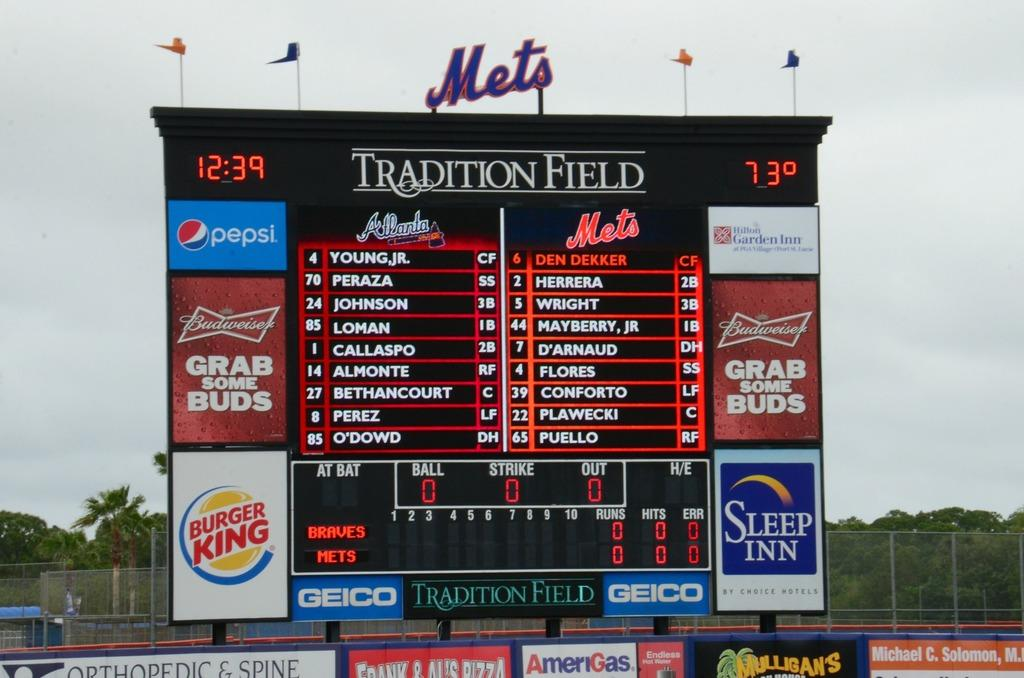Provide a one-sentence caption for the provided image. A large sign has the Mets logo on top. 